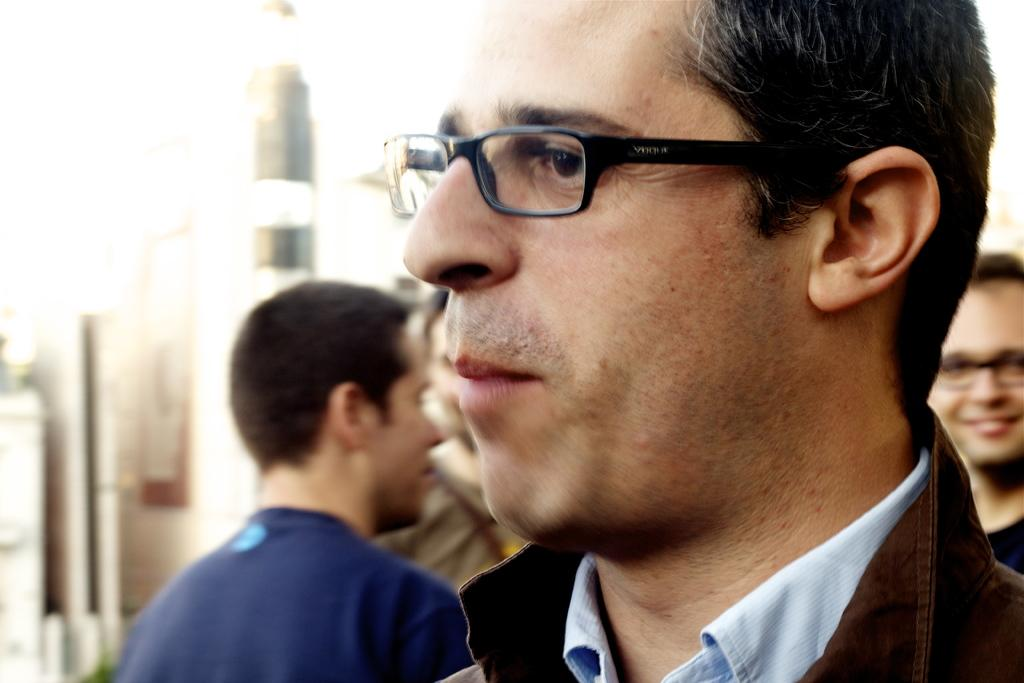What can be seen in the image? There is a group of people in the image. Can you describe the appearance of some individuals in the group? Some persons in the group are wearing spectacles. What else is visible in the image besides the group of people? There are objects visible in the background of the image. Is the sister of one of the persons in the group present at the party in the image? There is no mention of a sister or a party in the image, so it cannot be determined if the sister is present. 